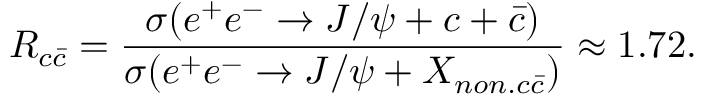<formula> <loc_0><loc_0><loc_500><loc_500>R _ { c \bar { c } } = \frac { \sigma ( e ^ { + } e ^ { - } \to J / \psi + c + \bar { c } ) } { \sigma ( e ^ { + } e ^ { - } \to J / \psi + X _ { n o n . c \bar { c } } ) } \approx 1 . 7 2 .</formula> 